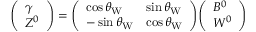<formula> <loc_0><loc_0><loc_500><loc_500>{ \left ( \begin{array} { l } { \gamma } \\ { Z ^ { 0 } } \end{array} \right ) } = { \left ( \begin{array} { l l } { \cos \theta _ { W } } & { \sin \theta _ { W } } \\ { - \sin \theta _ { W } } & { \cos \theta _ { W } } \end{array} \right ) } { \left ( \begin{array} { l } { B ^ { 0 } } \\ { W ^ { 0 } } \end{array} \right ) }</formula> 